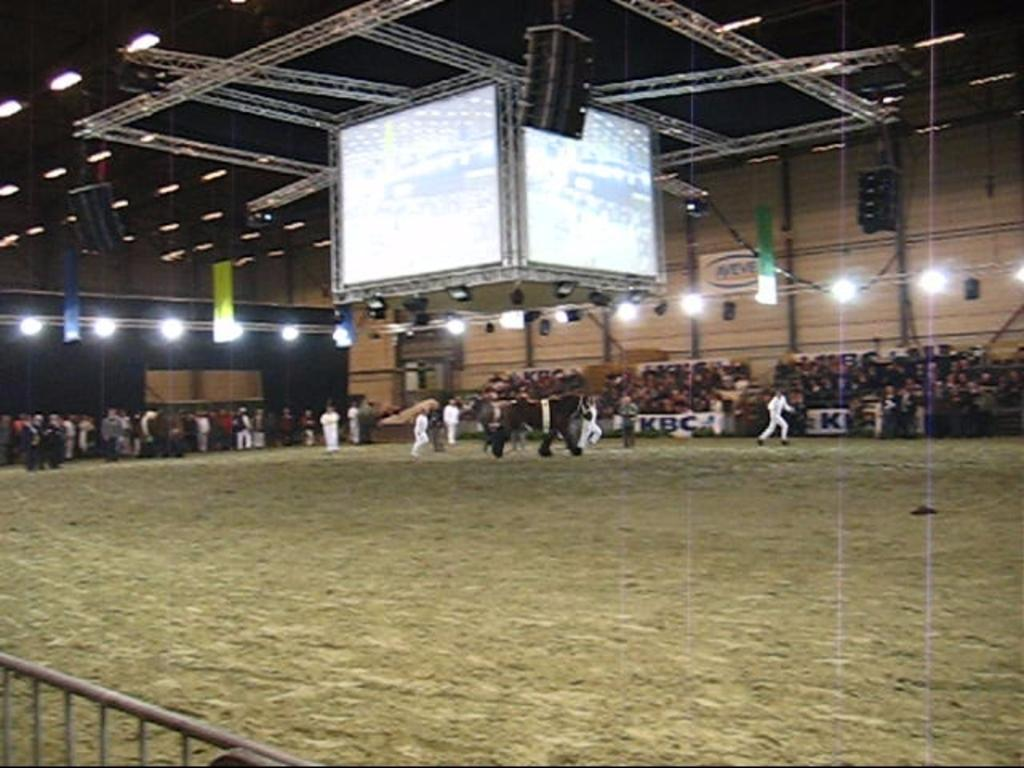How many people are in the image? There are many people in the image. What is the position of the people in the image? The people are on the ground. What can be seen in the image that provides illumination? There are lights visible in the image. What is located at the roof in the image? There is a screen at the roof in the image. What type of lock is used to secure the record on the screen in the image? There is no lock or record present in the image; it only features people on the ground, lights, and a screen at the roof. 